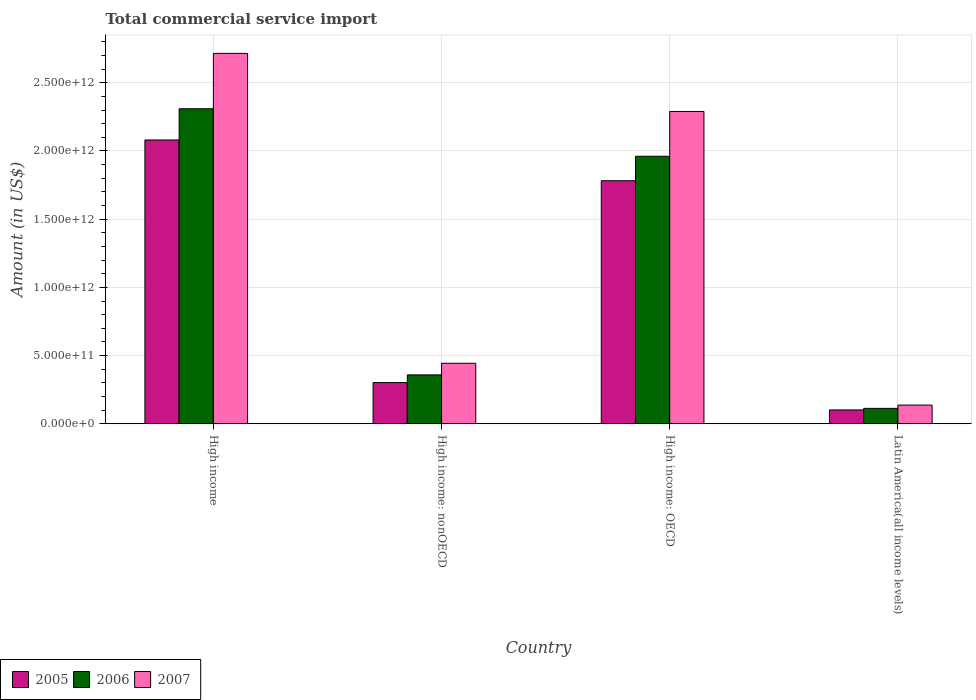How many different coloured bars are there?
Provide a short and direct response. 3. Are the number of bars on each tick of the X-axis equal?
Keep it short and to the point. Yes. What is the label of the 2nd group of bars from the left?
Your response must be concise. High income: nonOECD. What is the total commercial service import in 2007 in High income: nonOECD?
Offer a terse response. 4.44e+11. Across all countries, what is the maximum total commercial service import in 2006?
Give a very brief answer. 2.31e+12. Across all countries, what is the minimum total commercial service import in 2006?
Your response must be concise. 1.13e+11. In which country was the total commercial service import in 2005 maximum?
Provide a succinct answer. High income. In which country was the total commercial service import in 2005 minimum?
Provide a succinct answer. Latin America(all income levels). What is the total total commercial service import in 2005 in the graph?
Keep it short and to the point. 4.27e+12. What is the difference between the total commercial service import in 2006 in High income and that in High income: OECD?
Make the answer very short. 3.48e+11. What is the difference between the total commercial service import in 2006 in High income: OECD and the total commercial service import in 2005 in High income?
Give a very brief answer. -1.19e+11. What is the average total commercial service import in 2007 per country?
Your answer should be very brief. 1.40e+12. What is the difference between the total commercial service import of/in 2005 and total commercial service import of/in 2006 in High income?
Your answer should be compact. -2.29e+11. What is the ratio of the total commercial service import in 2006 in High income: nonOECD to that in Latin America(all income levels)?
Provide a short and direct response. 3.18. What is the difference between the highest and the second highest total commercial service import in 2006?
Provide a short and direct response. 3.48e+11. What is the difference between the highest and the lowest total commercial service import in 2007?
Your answer should be compact. 2.58e+12. In how many countries, is the total commercial service import in 2007 greater than the average total commercial service import in 2007 taken over all countries?
Keep it short and to the point. 2. Is the sum of the total commercial service import in 2006 in High income and High income: OECD greater than the maximum total commercial service import in 2007 across all countries?
Provide a short and direct response. Yes. What does the 1st bar from the left in Latin America(all income levels) represents?
Your answer should be very brief. 2005. What is the difference between two consecutive major ticks on the Y-axis?
Make the answer very short. 5.00e+11. Are the values on the major ticks of Y-axis written in scientific E-notation?
Make the answer very short. Yes. What is the title of the graph?
Make the answer very short. Total commercial service import. What is the label or title of the Y-axis?
Offer a terse response. Amount (in US$). What is the Amount (in US$) of 2005 in High income?
Provide a succinct answer. 2.08e+12. What is the Amount (in US$) in 2006 in High income?
Keep it short and to the point. 2.31e+12. What is the Amount (in US$) in 2007 in High income?
Make the answer very short. 2.72e+12. What is the Amount (in US$) of 2005 in High income: nonOECD?
Your answer should be very brief. 3.02e+11. What is the Amount (in US$) in 2006 in High income: nonOECD?
Provide a succinct answer. 3.58e+11. What is the Amount (in US$) in 2007 in High income: nonOECD?
Provide a succinct answer. 4.44e+11. What is the Amount (in US$) of 2005 in High income: OECD?
Ensure brevity in your answer.  1.78e+12. What is the Amount (in US$) of 2006 in High income: OECD?
Provide a succinct answer. 1.96e+12. What is the Amount (in US$) in 2007 in High income: OECD?
Your response must be concise. 2.29e+12. What is the Amount (in US$) of 2005 in Latin America(all income levels)?
Provide a succinct answer. 1.01e+11. What is the Amount (in US$) in 2006 in Latin America(all income levels)?
Make the answer very short. 1.13e+11. What is the Amount (in US$) of 2007 in Latin America(all income levels)?
Ensure brevity in your answer.  1.37e+11. Across all countries, what is the maximum Amount (in US$) of 2005?
Make the answer very short. 2.08e+12. Across all countries, what is the maximum Amount (in US$) in 2006?
Your answer should be compact. 2.31e+12. Across all countries, what is the maximum Amount (in US$) in 2007?
Your answer should be very brief. 2.72e+12. Across all countries, what is the minimum Amount (in US$) of 2005?
Provide a short and direct response. 1.01e+11. Across all countries, what is the minimum Amount (in US$) in 2006?
Ensure brevity in your answer.  1.13e+11. Across all countries, what is the minimum Amount (in US$) of 2007?
Offer a very short reply. 1.37e+11. What is the total Amount (in US$) of 2005 in the graph?
Your answer should be very brief. 4.27e+12. What is the total Amount (in US$) in 2006 in the graph?
Keep it short and to the point. 4.74e+12. What is the total Amount (in US$) of 2007 in the graph?
Provide a succinct answer. 5.59e+12. What is the difference between the Amount (in US$) in 2005 in High income and that in High income: nonOECD?
Offer a very short reply. 1.78e+12. What is the difference between the Amount (in US$) in 2006 in High income and that in High income: nonOECD?
Ensure brevity in your answer.  1.95e+12. What is the difference between the Amount (in US$) of 2007 in High income and that in High income: nonOECD?
Your answer should be compact. 2.27e+12. What is the difference between the Amount (in US$) of 2005 in High income and that in High income: OECD?
Offer a very short reply. 2.99e+11. What is the difference between the Amount (in US$) of 2006 in High income and that in High income: OECD?
Provide a succinct answer. 3.48e+11. What is the difference between the Amount (in US$) in 2007 in High income and that in High income: OECD?
Offer a very short reply. 4.26e+11. What is the difference between the Amount (in US$) of 2005 in High income and that in Latin America(all income levels)?
Make the answer very short. 1.98e+12. What is the difference between the Amount (in US$) of 2006 in High income and that in Latin America(all income levels)?
Your response must be concise. 2.20e+12. What is the difference between the Amount (in US$) of 2007 in High income and that in Latin America(all income levels)?
Provide a succinct answer. 2.58e+12. What is the difference between the Amount (in US$) in 2005 in High income: nonOECD and that in High income: OECD?
Your answer should be compact. -1.48e+12. What is the difference between the Amount (in US$) of 2006 in High income: nonOECD and that in High income: OECD?
Provide a succinct answer. -1.60e+12. What is the difference between the Amount (in US$) of 2007 in High income: nonOECD and that in High income: OECD?
Your answer should be compact. -1.85e+12. What is the difference between the Amount (in US$) in 2005 in High income: nonOECD and that in Latin America(all income levels)?
Offer a terse response. 2.00e+11. What is the difference between the Amount (in US$) in 2006 in High income: nonOECD and that in Latin America(all income levels)?
Offer a very short reply. 2.46e+11. What is the difference between the Amount (in US$) in 2007 in High income: nonOECD and that in Latin America(all income levels)?
Ensure brevity in your answer.  3.07e+11. What is the difference between the Amount (in US$) in 2005 in High income: OECD and that in Latin America(all income levels)?
Keep it short and to the point. 1.68e+12. What is the difference between the Amount (in US$) in 2006 in High income: OECD and that in Latin America(all income levels)?
Offer a terse response. 1.85e+12. What is the difference between the Amount (in US$) in 2007 in High income: OECD and that in Latin America(all income levels)?
Offer a terse response. 2.15e+12. What is the difference between the Amount (in US$) of 2005 in High income and the Amount (in US$) of 2006 in High income: nonOECD?
Keep it short and to the point. 1.72e+12. What is the difference between the Amount (in US$) in 2005 in High income and the Amount (in US$) in 2007 in High income: nonOECD?
Your answer should be very brief. 1.64e+12. What is the difference between the Amount (in US$) of 2006 in High income and the Amount (in US$) of 2007 in High income: nonOECD?
Offer a terse response. 1.87e+12. What is the difference between the Amount (in US$) in 2005 in High income and the Amount (in US$) in 2006 in High income: OECD?
Offer a very short reply. 1.19e+11. What is the difference between the Amount (in US$) of 2005 in High income and the Amount (in US$) of 2007 in High income: OECD?
Offer a terse response. -2.09e+11. What is the difference between the Amount (in US$) in 2006 in High income and the Amount (in US$) in 2007 in High income: OECD?
Provide a short and direct response. 1.98e+1. What is the difference between the Amount (in US$) in 2005 in High income and the Amount (in US$) in 2006 in Latin America(all income levels)?
Provide a succinct answer. 1.97e+12. What is the difference between the Amount (in US$) in 2005 in High income and the Amount (in US$) in 2007 in Latin America(all income levels)?
Your answer should be compact. 1.94e+12. What is the difference between the Amount (in US$) in 2006 in High income and the Amount (in US$) in 2007 in Latin America(all income levels)?
Provide a short and direct response. 2.17e+12. What is the difference between the Amount (in US$) of 2005 in High income: nonOECD and the Amount (in US$) of 2006 in High income: OECD?
Your answer should be compact. -1.66e+12. What is the difference between the Amount (in US$) in 2005 in High income: nonOECD and the Amount (in US$) in 2007 in High income: OECD?
Provide a short and direct response. -1.99e+12. What is the difference between the Amount (in US$) of 2006 in High income: nonOECD and the Amount (in US$) of 2007 in High income: OECD?
Give a very brief answer. -1.93e+12. What is the difference between the Amount (in US$) in 2005 in High income: nonOECD and the Amount (in US$) in 2006 in Latin America(all income levels)?
Give a very brief answer. 1.89e+11. What is the difference between the Amount (in US$) of 2005 in High income: nonOECD and the Amount (in US$) of 2007 in Latin America(all income levels)?
Provide a succinct answer. 1.65e+11. What is the difference between the Amount (in US$) in 2006 in High income: nonOECD and the Amount (in US$) in 2007 in Latin America(all income levels)?
Your answer should be compact. 2.22e+11. What is the difference between the Amount (in US$) of 2005 in High income: OECD and the Amount (in US$) of 2006 in Latin America(all income levels)?
Make the answer very short. 1.67e+12. What is the difference between the Amount (in US$) in 2005 in High income: OECD and the Amount (in US$) in 2007 in Latin America(all income levels)?
Keep it short and to the point. 1.65e+12. What is the difference between the Amount (in US$) in 2006 in High income: OECD and the Amount (in US$) in 2007 in Latin America(all income levels)?
Offer a terse response. 1.82e+12. What is the average Amount (in US$) in 2005 per country?
Your response must be concise. 1.07e+12. What is the average Amount (in US$) of 2006 per country?
Provide a succinct answer. 1.19e+12. What is the average Amount (in US$) of 2007 per country?
Provide a short and direct response. 1.40e+12. What is the difference between the Amount (in US$) in 2005 and Amount (in US$) in 2006 in High income?
Offer a very short reply. -2.29e+11. What is the difference between the Amount (in US$) in 2005 and Amount (in US$) in 2007 in High income?
Offer a very short reply. -6.35e+11. What is the difference between the Amount (in US$) in 2006 and Amount (in US$) in 2007 in High income?
Offer a very short reply. -4.06e+11. What is the difference between the Amount (in US$) in 2005 and Amount (in US$) in 2006 in High income: nonOECD?
Your response must be concise. -5.66e+1. What is the difference between the Amount (in US$) of 2005 and Amount (in US$) of 2007 in High income: nonOECD?
Your answer should be very brief. -1.42e+11. What is the difference between the Amount (in US$) in 2006 and Amount (in US$) in 2007 in High income: nonOECD?
Provide a short and direct response. -8.52e+1. What is the difference between the Amount (in US$) of 2005 and Amount (in US$) of 2006 in High income: OECD?
Your answer should be very brief. -1.79e+11. What is the difference between the Amount (in US$) of 2005 and Amount (in US$) of 2007 in High income: OECD?
Provide a succinct answer. -5.08e+11. What is the difference between the Amount (in US$) in 2006 and Amount (in US$) in 2007 in High income: OECD?
Offer a terse response. -3.29e+11. What is the difference between the Amount (in US$) in 2005 and Amount (in US$) in 2006 in Latin America(all income levels)?
Give a very brief answer. -1.15e+1. What is the difference between the Amount (in US$) in 2005 and Amount (in US$) in 2007 in Latin America(all income levels)?
Your answer should be very brief. -3.55e+1. What is the difference between the Amount (in US$) in 2006 and Amount (in US$) in 2007 in Latin America(all income levels)?
Provide a short and direct response. -2.40e+1. What is the ratio of the Amount (in US$) of 2005 in High income to that in High income: nonOECD?
Make the answer very short. 6.9. What is the ratio of the Amount (in US$) of 2006 in High income to that in High income: nonOECD?
Your response must be concise. 6.45. What is the ratio of the Amount (in US$) of 2007 in High income to that in High income: nonOECD?
Ensure brevity in your answer.  6.12. What is the ratio of the Amount (in US$) of 2005 in High income to that in High income: OECD?
Provide a succinct answer. 1.17. What is the ratio of the Amount (in US$) of 2006 in High income to that in High income: OECD?
Your answer should be very brief. 1.18. What is the ratio of the Amount (in US$) of 2007 in High income to that in High income: OECD?
Make the answer very short. 1.19. What is the ratio of the Amount (in US$) in 2005 in High income to that in Latin America(all income levels)?
Ensure brevity in your answer.  20.56. What is the ratio of the Amount (in US$) in 2006 in High income to that in Latin America(all income levels)?
Provide a short and direct response. 20.5. What is the ratio of the Amount (in US$) in 2007 in High income to that in Latin America(all income levels)?
Provide a succinct answer. 19.87. What is the ratio of the Amount (in US$) in 2005 in High income: nonOECD to that in High income: OECD?
Offer a very short reply. 0.17. What is the ratio of the Amount (in US$) in 2006 in High income: nonOECD to that in High income: OECD?
Provide a short and direct response. 0.18. What is the ratio of the Amount (in US$) in 2007 in High income: nonOECD to that in High income: OECD?
Provide a succinct answer. 0.19. What is the ratio of the Amount (in US$) of 2005 in High income: nonOECD to that in Latin America(all income levels)?
Offer a terse response. 2.98. What is the ratio of the Amount (in US$) of 2006 in High income: nonOECD to that in Latin America(all income levels)?
Your response must be concise. 3.18. What is the ratio of the Amount (in US$) in 2007 in High income: nonOECD to that in Latin America(all income levels)?
Keep it short and to the point. 3.25. What is the ratio of the Amount (in US$) of 2005 in High income: OECD to that in Latin America(all income levels)?
Ensure brevity in your answer.  17.6. What is the ratio of the Amount (in US$) in 2006 in High income: OECD to that in Latin America(all income levels)?
Keep it short and to the point. 17.4. What is the ratio of the Amount (in US$) of 2007 in High income: OECD to that in Latin America(all income levels)?
Provide a succinct answer. 16.75. What is the difference between the highest and the second highest Amount (in US$) of 2005?
Offer a very short reply. 2.99e+11. What is the difference between the highest and the second highest Amount (in US$) of 2006?
Your answer should be compact. 3.48e+11. What is the difference between the highest and the second highest Amount (in US$) in 2007?
Offer a very short reply. 4.26e+11. What is the difference between the highest and the lowest Amount (in US$) in 2005?
Your answer should be very brief. 1.98e+12. What is the difference between the highest and the lowest Amount (in US$) of 2006?
Give a very brief answer. 2.20e+12. What is the difference between the highest and the lowest Amount (in US$) of 2007?
Offer a terse response. 2.58e+12. 